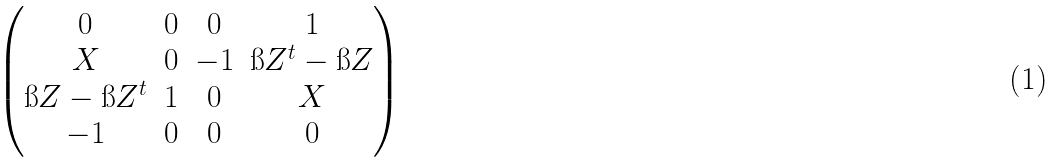Convert formula to latex. <formula><loc_0><loc_0><loc_500><loc_500>\begin{pmatrix} 0 & 0 & 0 & 1 \\ X & 0 & - 1 & \i Z ^ { t } - \i Z \\ \i Z - \i Z ^ { t } & 1 & 0 & X \\ - 1 & 0 & 0 & 0 \end{pmatrix}</formula> 